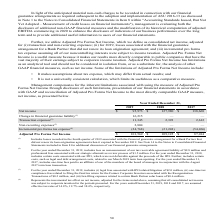From Greensky's financial document, Which years does the table provide? The document contains multiple relevant values: 2019, 2018, 2017. From the document: "Year Ended December 31, 2019 2018 2017 Year Ended December 31, 2019 2018 2017 Year Ended December 31, 2019 2018 2017..." Also, What was the Change in financial guarantee liability in 2019? According to the financial document, 16,215 (in thousands). The relevant text states: "Change in financial guarantee liability (1) 16,215 — —..." Also, What does Incremental pro forma tax expense represent? the incremental tax effect on net income, adjusted for the items noted above, assuming that all consolidated net income was subject to corporate taxation for the periods presented.. The document states: "(4) Represents the incremental tax effect on net income, adjusted for the items noted above, assuming that all consolidated net income was subject to ..." Also, How many years did Adjusted Pro Forma Net Income exceed $100,000 thousand? Counting the relevant items in the document: 2019, 2018, I find 2 instances. The key data points involved are: 2018, 2019. Also, can you calculate: What was the change in net income between 2017 and 2018? Based on the calculation: 127,980-138,668, the result is -10688 (in thousands). This is based on the information: "Net income $ 95,973 $ 127,980 $ 138,668 Net income $ 95,973 $ 127,980 $ 138,668..." The key data points involved are: 127,980, 138,668. Also, can you calculate: What was the percentage change in Transaction expenses between 2018 and 2019? To answer this question, I need to perform calculations using the financial data. The calculation is: (11,345-2,393)/2,393, which equals 374.09 (percentage). This is based on the information: "Transaction expenses (2) 11,345 2,393 2,612 Transaction expenses (2) 11,345 2,393 2,612..." The key data points involved are: 11,345, 2,393. 